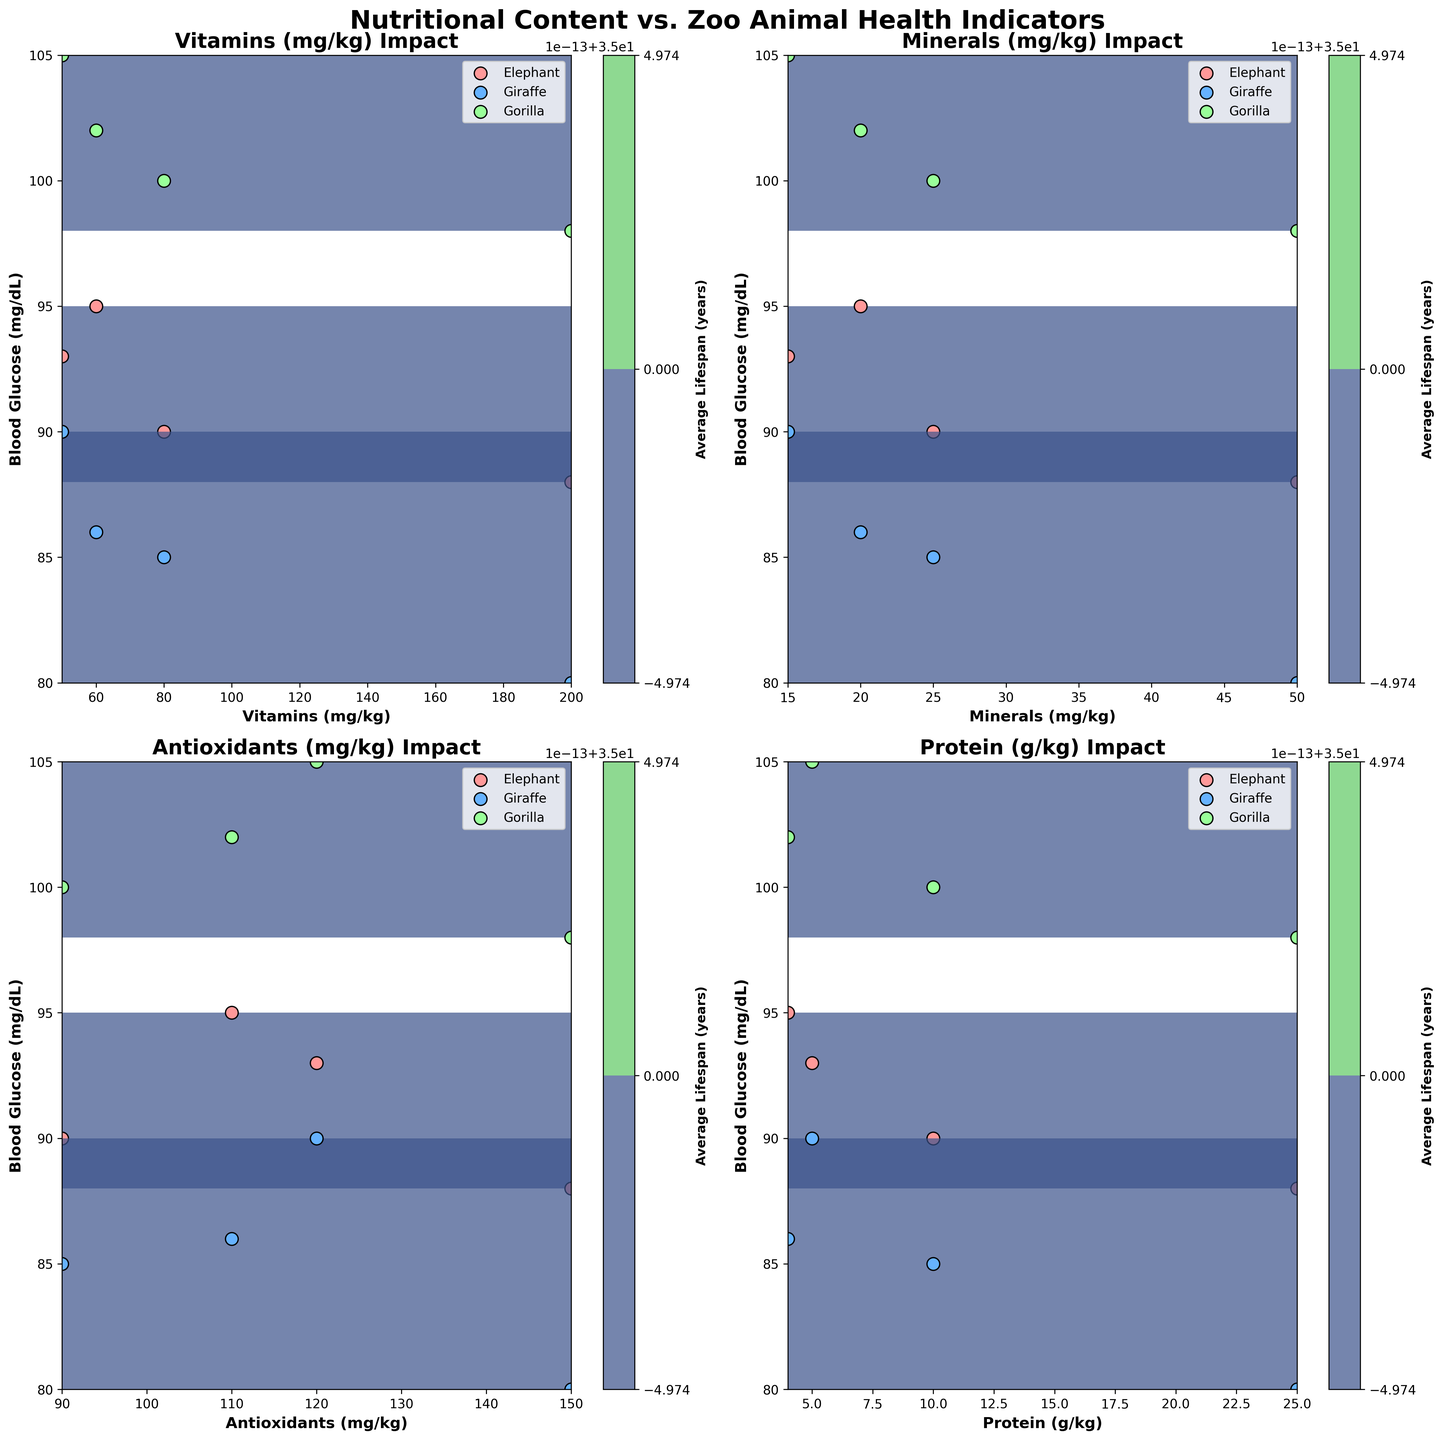Which subtype has the highest blood glucose level for bananas? We observe that blood glucose levels for bananas (in yellow) are highest for gorillas. By looking at the yellow contour for the glucose levels, gorillas have the highest visual scatter data point on the y-axis, which is higher than elephants and giraffes.
Answer: Gorilla Does average lifespan increase with spinach consumption across all animals? Looking at the spinach subplot, increasing vitamins, minerals, antioxidants, and protein seems to increase the density of higher average lifespan contours for all animals, especially for elephants, giraffes, and gorillas. This suggests that lifespan increases with spinach consumption.
Answer: Yes Which nutrient has the greatest positive impact on blood glucose for gorillas? By comparing all the subplots, we see that the banana subplot (in yellow) has the highest blood glucose levels. However, for gorillas specifically, the blood glucose levels are highest with apples (scatter point highest on y-axis) and spinach nutrients in terms of contour concentration and scatter points.
Answer: Apples How does mineral intake influence blood glucose for elephants? From the mineral subplot, elephants are marked in red. Observing the scatter points and contours on the graph, there is a moderate-level and consistent glucose level for varying mineral intake suggesting a moderate positive correlation.
Answer: Moderate positive correlation What is the general trend between antioxidants and blood glucose levels for giraffes? In the antioxidants subplot, giraffes are marked in blue. Observing the scatter points, it shows there is an upward scatter trend and contour suggesting a positive trend of blood glucose levels corresponding to antioxidant intake.
Answer: Positive trend Which animal has the longest average lifespan with the carrot diet? Observing the contour levels and scatter points for the carrot subplot, gorillas marked in green show higher scatter plot points in terms of average years, indicating they have the longest average lifespan with a carrot diet.
Answer: Gorilla Which nutrient seems to influence elephants' blood glucose the least? By comparing all subplots with elephants' data (in red), we see that vitamins have relatively consistent and unaffected changes in blood glucose levels suggesting the least influence.
Answer: Vitamins 